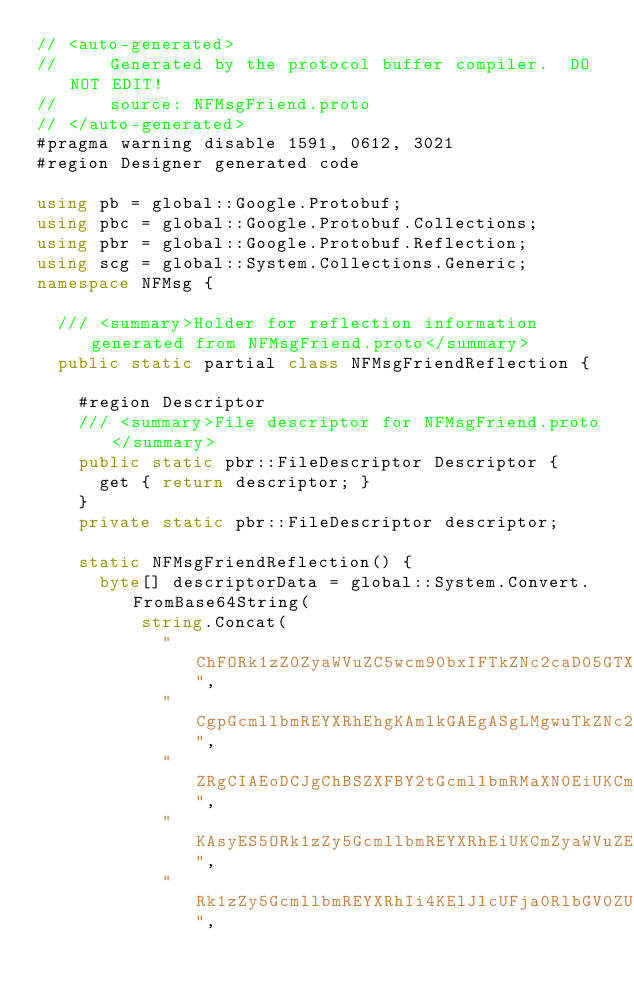<code> <loc_0><loc_0><loc_500><loc_500><_C#_>// <auto-generated>
//     Generated by the protocol buffer compiler.  DO NOT EDIT!
//     source: NFMsgFriend.proto
// </auto-generated>
#pragma warning disable 1591, 0612, 3021
#region Designer generated code

using pb = global::Google.Protobuf;
using pbc = global::Google.Protobuf.Collections;
using pbr = global::Google.Protobuf.Reflection;
using scg = global::System.Collections.Generic;
namespace NFMsg {

  /// <summary>Holder for reflection information generated from NFMsgFriend.proto</summary>
  public static partial class NFMsgFriendReflection {

    #region Descriptor
    /// <summary>File descriptor for NFMsgFriend.proto</summary>
    public static pbr::FileDescriptor Descriptor {
      get { return descriptor; }
    }
    private static pbr::FileDescriptor descriptor;

    static NFMsgFriendReflection() {
      byte[] descriptorData = global::System.Convert.FromBase64String(
          string.Concat(
            "ChFORk1zZ0ZyaWVuZC5wcm90bxIFTkZNc2caD05GTXNnQmFzZS5wcm90byI0",
            "CgpGcmllbmREYXRhEhgKAmlkGAEgASgLMgwuTkZNc2cuSWRlbnQSDAoEbmFt",
            "ZRgCIAEoDCJgChBSZXFBY2tGcmllbmRMaXN0EiUKCmludml0ZUxpc3QYASAD",
            "KAsyES5ORk1zZy5GcmllbmREYXRhEiUKCmZyaWVuZExpc3QYAiADKAsyES5O",
            "Rk1zZy5GcmllbmREYXRhIi4KElJlcUFja0RlbGV0ZUZyaWVuZBIYCgJpZBgB",</code> 